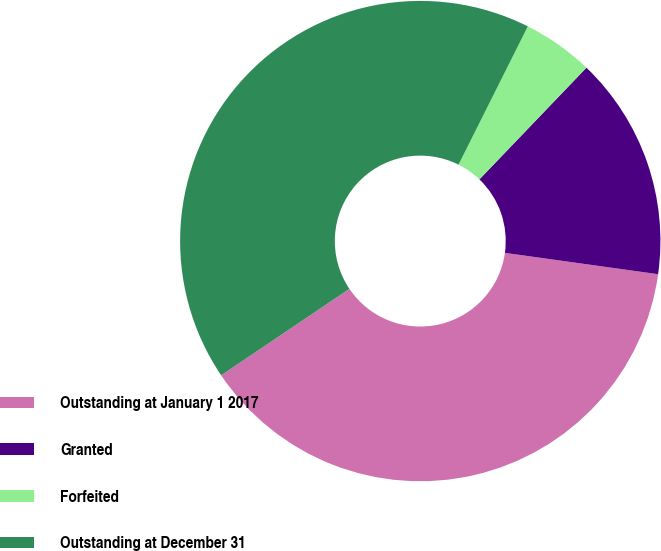Convert chart to OTSL. <chart><loc_0><loc_0><loc_500><loc_500><pie_chart><fcel>Outstanding at January 1 2017<fcel>Granted<fcel>Forfeited<fcel>Outstanding at December 31<nl><fcel>38.35%<fcel>15.04%<fcel>4.77%<fcel>41.83%<nl></chart> 